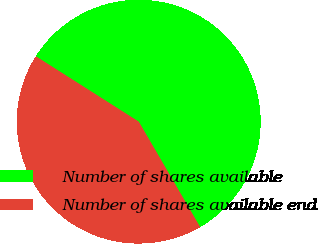Convert chart to OTSL. <chart><loc_0><loc_0><loc_500><loc_500><pie_chart><fcel>Number of shares available<fcel>Number of shares available end<nl><fcel>57.6%<fcel>42.4%<nl></chart> 